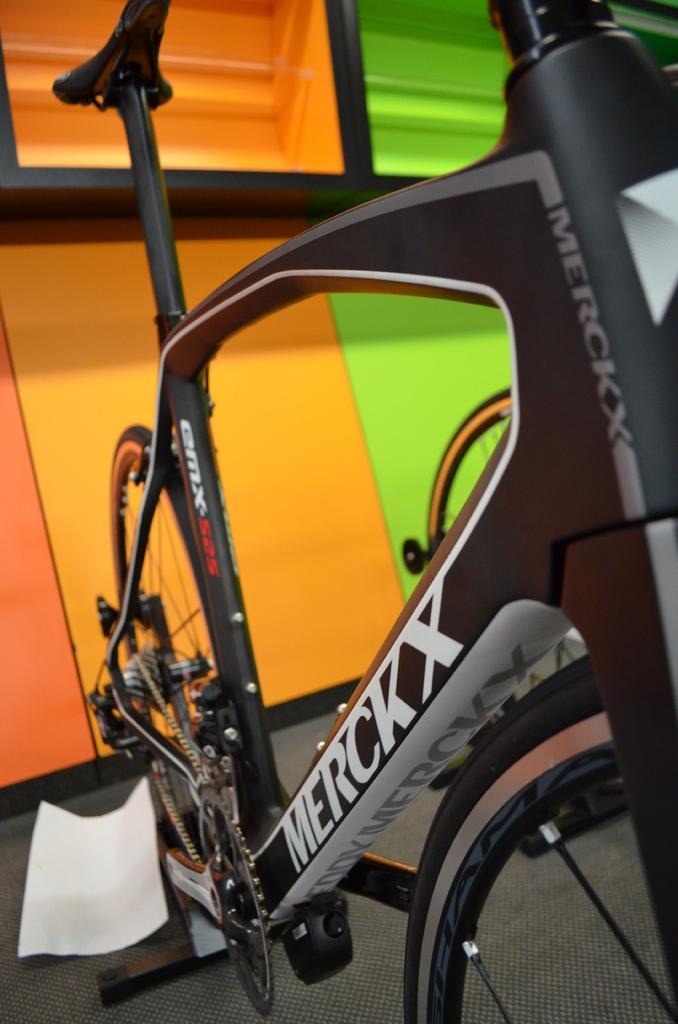What is the main object in the image? There is a bicycle in the image. What color is the bicycle? The bicycle is black. What can be seen in the background of the image? There is a wall in the background of the image. What colors are present on the wall? The wall has orange and green colors. Is there a baseball game happening in the image? There is no indication of a baseball game or any baseball-related elements in the image. 